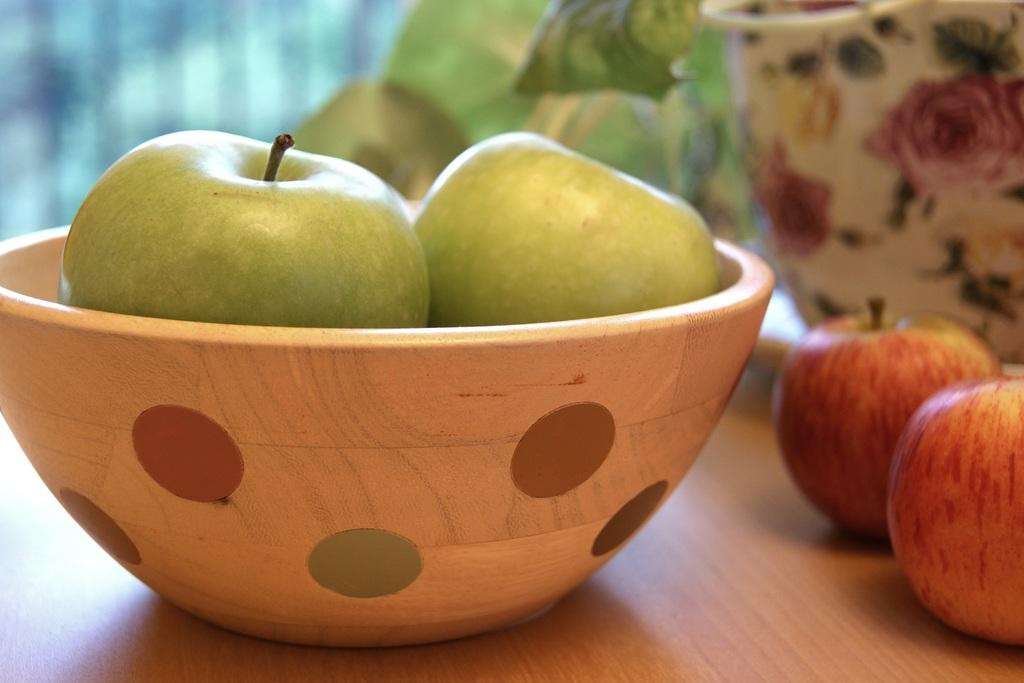What is located in the foreground of the image? There is a bowl in the foreground of the image. What is inside the bowl? The bowl contains apples. What else can be seen on the table in the image? There are jars on the table. Where might this image have been taken? The image is likely taken in a room, as indicated by the presence of a wall in the background. Can you tell me what type of squirrel is sitting on the judge's shoulder in the image? There is no squirrel or judge present in the image; it features a bowl of apples and jars on a table in a room. 